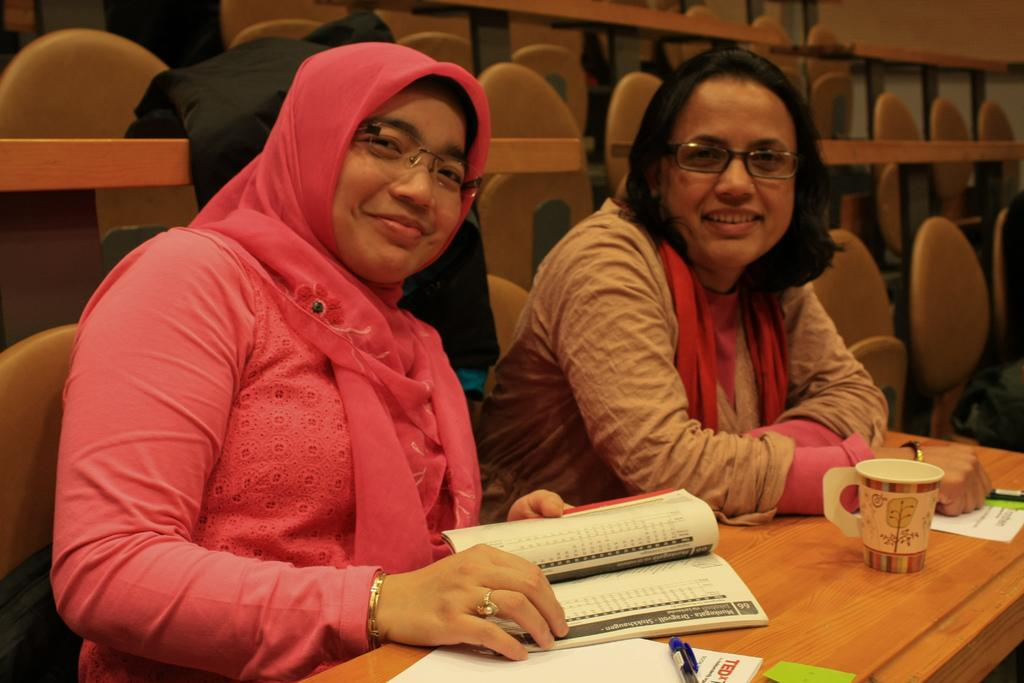How many women are in the image? There are 2 women in the image. What are the women doing in the image? The women are sitting on chairs. What is in front of the women? There is a table in front of the women. What items can be seen on the table? There is a cup, 2 books, and a pen on the table. What can be seen in the background of the image? There is a cloth and chairs in the background of the image. What type of button can be seen on the list in the image? There is no list or button present in the image. What is the color of the moon in the image? There is no moon present in the image. 